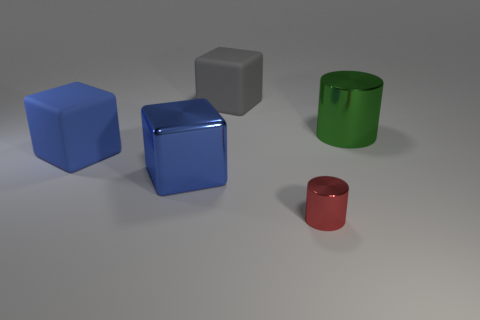How does the lighting in this image affect the appearance of the objects? The lighting in the image creates soft shadows and highlights on the objects, which enhances the three-dimensional effect and provides a sense of depth. The reflective surfaces also show slight specular highlights, giving the viewer clues about the curvature and texture of the objects. 